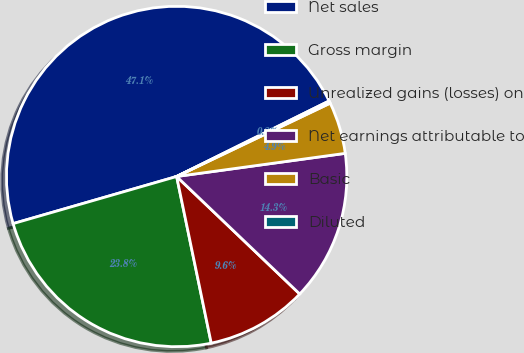Convert chart. <chart><loc_0><loc_0><loc_500><loc_500><pie_chart><fcel>Net sales<fcel>Gross margin<fcel>Unrealized gains (losses) on<fcel>Net earnings attributable to<fcel>Basic<fcel>Diluted<nl><fcel>47.14%<fcel>23.79%<fcel>9.61%<fcel>14.3%<fcel>4.92%<fcel>0.23%<nl></chart> 